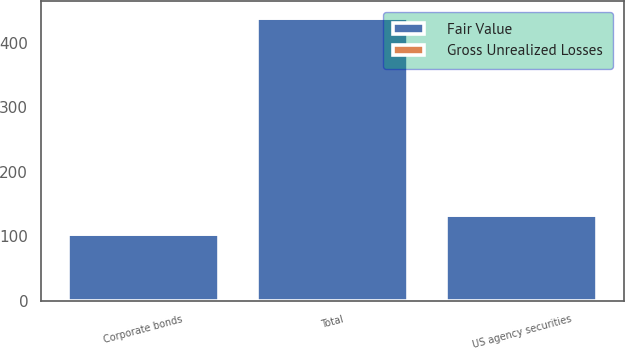Convert chart to OTSL. <chart><loc_0><loc_0><loc_500><loc_500><stacked_bar_chart><ecel><fcel>US agency securities<fcel>Corporate bonds<fcel>Total<nl><fcel>Fair Value<fcel>133<fcel>104<fcel>439<nl><fcel>Gross Unrealized Losses<fcel>1<fcel>1<fcel>3<nl></chart> 